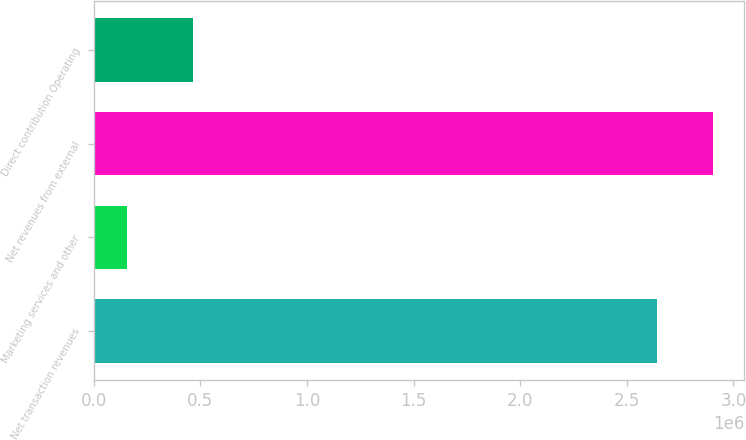Convert chart. <chart><loc_0><loc_0><loc_500><loc_500><bar_chart><fcel>Net transaction revenues<fcel>Marketing services and other<fcel>Net revenues from external<fcel>Direct contribution Operating<nl><fcel>2.64119e+06<fcel>154751<fcel>2.90531e+06<fcel>463382<nl></chart> 